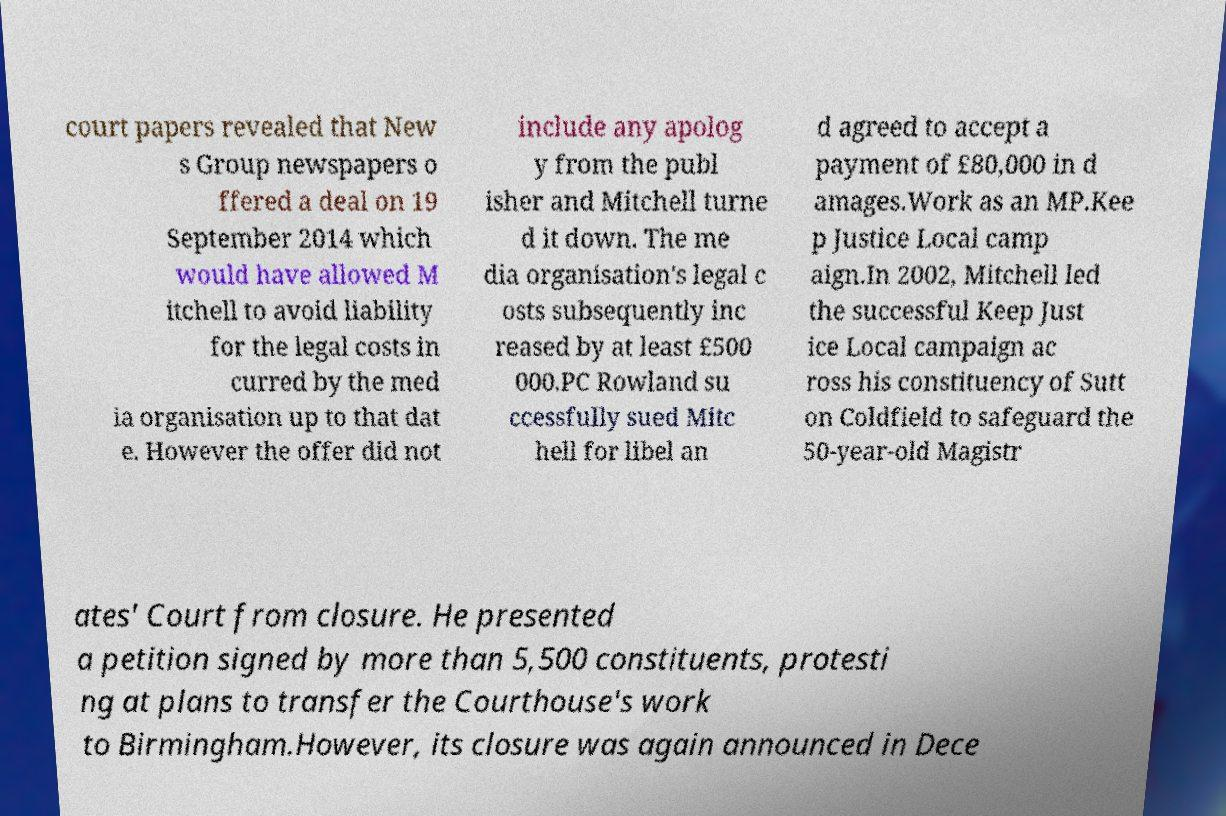For documentation purposes, I need the text within this image transcribed. Could you provide that? court papers revealed that New s Group newspapers o ffered a deal on 19 September 2014 which would have allowed M itchell to avoid liability for the legal costs in curred by the med ia organisation up to that dat e. However the offer did not include any apolog y from the publ isher and Mitchell turne d it down. The me dia organisation's legal c osts subsequently inc reased by at least £500 000.PC Rowland su ccessfully sued Mitc hell for libel an d agreed to accept a payment of £80,000 in d amages.Work as an MP.Kee p Justice Local camp aign.In 2002, Mitchell led the successful Keep Just ice Local campaign ac ross his constituency of Sutt on Coldfield to safeguard the 50-year-old Magistr ates' Court from closure. He presented a petition signed by more than 5,500 constituents, protesti ng at plans to transfer the Courthouse's work to Birmingham.However, its closure was again announced in Dece 